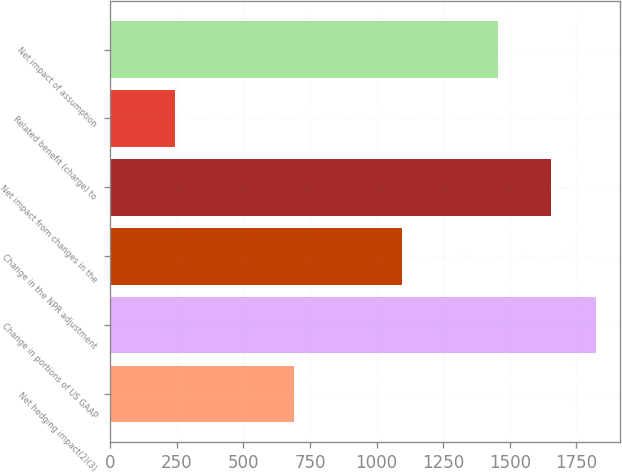Convert chart. <chart><loc_0><loc_0><loc_500><loc_500><bar_chart><fcel>Net hedging impact(2)(3)<fcel>Change in portions of US GAAP<fcel>Change in the NPR adjustment<fcel>Net impact from changes in the<fcel>Related benefit (charge) to<fcel>Net impact of assumption<nl><fcel>692<fcel>1824.1<fcel>1097<fcel>1654<fcel>243<fcel>1455<nl></chart> 